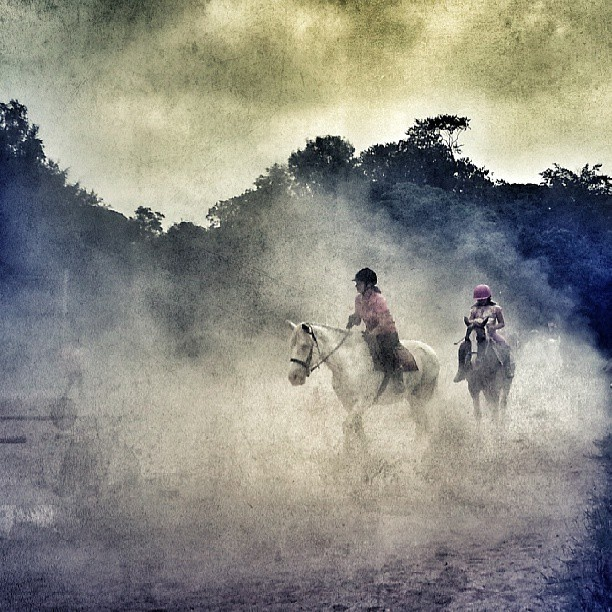Describe the objects in this image and their specific colors. I can see horse in darkgray, lightgray, and gray tones, people in darkgray, gray, and black tones, horse in darkgray, gray, black, and lightgray tones, people in darkgray, gray, black, and purple tones, and horse in lightgray and darkgray tones in this image. 